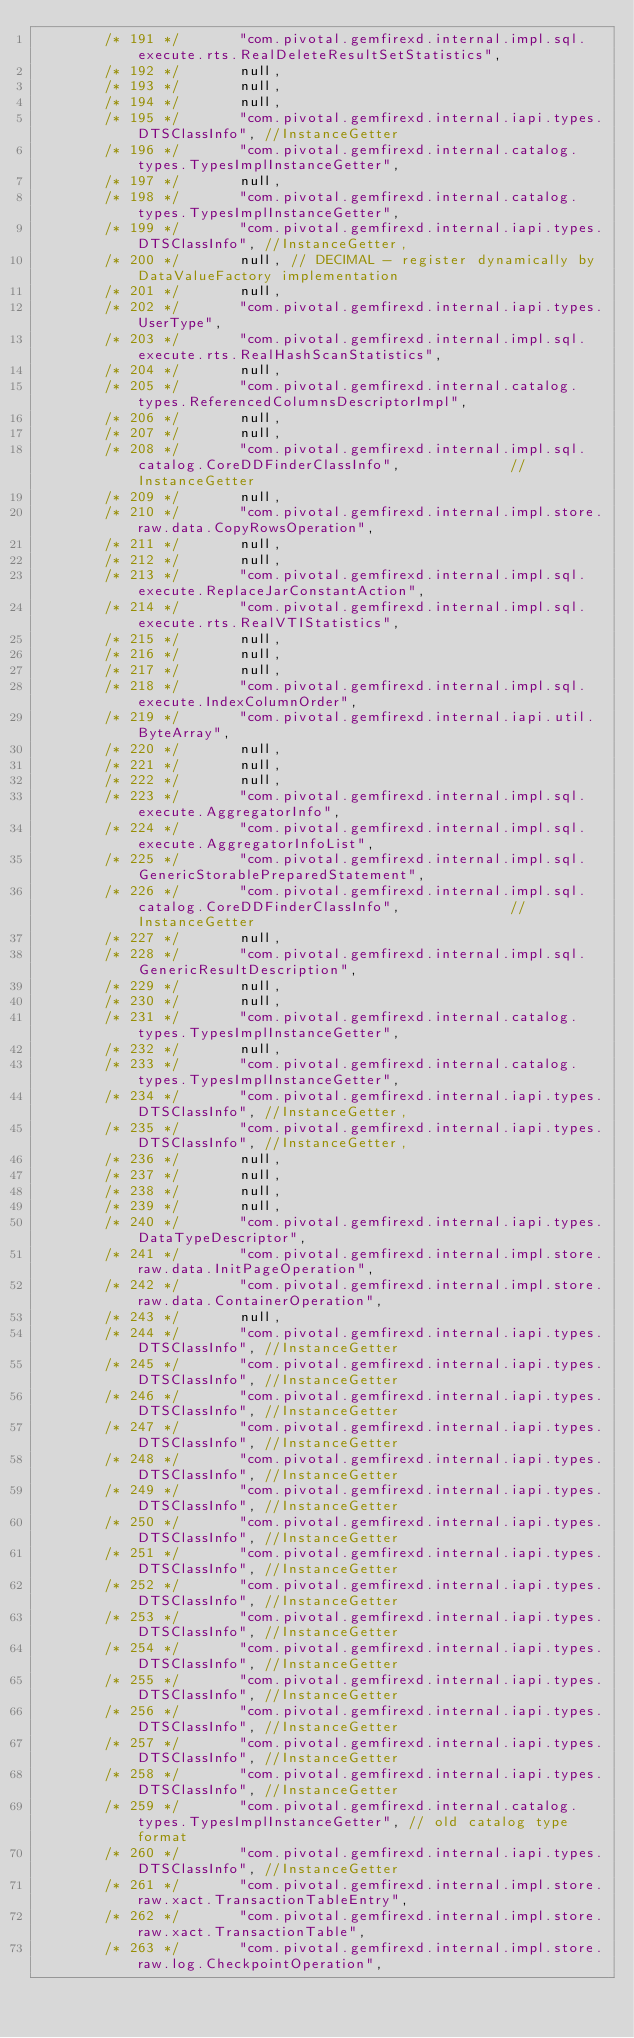<code> <loc_0><loc_0><loc_500><loc_500><_Java_>        /* 191 */       "com.pivotal.gemfirexd.internal.impl.sql.execute.rts.RealDeleteResultSetStatistics",
        /* 192 */       null,
        /* 193 */       null,
        /* 194 */       null,
        /* 195 */       "com.pivotal.gemfirexd.internal.iapi.types.DTSClassInfo", //InstanceGetter
        /* 196 */       "com.pivotal.gemfirexd.internal.catalog.types.TypesImplInstanceGetter",
        /* 197 */       null,
        /* 198 */       "com.pivotal.gemfirexd.internal.catalog.types.TypesImplInstanceGetter",
        /* 199 */       "com.pivotal.gemfirexd.internal.iapi.types.DTSClassInfo", //InstanceGetter,
        /* 200 */       null, // DECIMAL - register dynamically by DataValueFactory implementation
        /* 201 */       null,
        /* 202 */       "com.pivotal.gemfirexd.internal.iapi.types.UserType",
        /* 203 */       "com.pivotal.gemfirexd.internal.impl.sql.execute.rts.RealHashScanStatistics",
        /* 204 */       null,
        /* 205 */       "com.pivotal.gemfirexd.internal.catalog.types.ReferencedColumnsDescriptorImpl",
        /* 206 */       null,
        /* 207 */       null,
        /* 208 */       "com.pivotal.gemfirexd.internal.impl.sql.catalog.CoreDDFinderClassInfo",             // InstanceGetter
        /* 209 */       null,
        /* 210 */       "com.pivotal.gemfirexd.internal.impl.store.raw.data.CopyRowsOperation",
        /* 211 */       null,
        /* 212 */       null,
        /* 213 */       "com.pivotal.gemfirexd.internal.impl.sql.execute.ReplaceJarConstantAction",
        /* 214 */       "com.pivotal.gemfirexd.internal.impl.sql.execute.rts.RealVTIStatistics",
        /* 215 */       null,
        /* 216 */       null,
        /* 217 */       null,
        /* 218 */       "com.pivotal.gemfirexd.internal.impl.sql.execute.IndexColumnOrder",
        /* 219 */       "com.pivotal.gemfirexd.internal.iapi.util.ByteArray",
        /* 220 */       null,
        /* 221 */       null,
        /* 222 */       null,
        /* 223 */       "com.pivotal.gemfirexd.internal.impl.sql.execute.AggregatorInfo",
        /* 224 */       "com.pivotal.gemfirexd.internal.impl.sql.execute.AggregatorInfoList",
        /* 225 */       "com.pivotal.gemfirexd.internal.impl.sql.GenericStorablePreparedStatement",
        /* 226 */       "com.pivotal.gemfirexd.internal.impl.sql.catalog.CoreDDFinderClassInfo",             // InstanceGetter
        /* 227 */       null,
        /* 228 */       "com.pivotal.gemfirexd.internal.impl.sql.GenericResultDescription",
        /* 229 */       null,
        /* 230 */       null,
        /* 231 */       "com.pivotal.gemfirexd.internal.catalog.types.TypesImplInstanceGetter",
        /* 232 */       null,
        /* 233 */       "com.pivotal.gemfirexd.internal.catalog.types.TypesImplInstanceGetter",
        /* 234 */       "com.pivotal.gemfirexd.internal.iapi.types.DTSClassInfo", //InstanceGetter,
        /* 235 */       "com.pivotal.gemfirexd.internal.iapi.types.DTSClassInfo", //InstanceGetter,
        /* 236 */       null,
        /* 237 */       null,
        /* 238 */       null,
        /* 239 */       null,
        /* 240 */       "com.pivotal.gemfirexd.internal.iapi.types.DataTypeDescriptor",
        /* 241 */       "com.pivotal.gemfirexd.internal.impl.store.raw.data.InitPageOperation",
        /* 242 */       "com.pivotal.gemfirexd.internal.impl.store.raw.data.ContainerOperation",
        /* 243 */       null,
        /* 244 */       "com.pivotal.gemfirexd.internal.iapi.types.DTSClassInfo", //InstanceGetter
        /* 245 */       "com.pivotal.gemfirexd.internal.iapi.types.DTSClassInfo", //InstanceGetter
        /* 246 */       "com.pivotal.gemfirexd.internal.iapi.types.DTSClassInfo", //InstanceGetter
        /* 247 */       "com.pivotal.gemfirexd.internal.iapi.types.DTSClassInfo", //InstanceGetter
        /* 248 */       "com.pivotal.gemfirexd.internal.iapi.types.DTSClassInfo", //InstanceGetter
        /* 249 */       "com.pivotal.gemfirexd.internal.iapi.types.DTSClassInfo", //InstanceGetter
        /* 250 */       "com.pivotal.gemfirexd.internal.iapi.types.DTSClassInfo", //InstanceGetter
        /* 251 */       "com.pivotal.gemfirexd.internal.iapi.types.DTSClassInfo", //InstanceGetter
        /* 252 */       "com.pivotal.gemfirexd.internal.iapi.types.DTSClassInfo", //InstanceGetter
        /* 253 */       "com.pivotal.gemfirexd.internal.iapi.types.DTSClassInfo", //InstanceGetter
        /* 254 */       "com.pivotal.gemfirexd.internal.iapi.types.DTSClassInfo", //InstanceGetter
        /* 255 */       "com.pivotal.gemfirexd.internal.iapi.types.DTSClassInfo", //InstanceGetter
        /* 256 */       "com.pivotal.gemfirexd.internal.iapi.types.DTSClassInfo", //InstanceGetter
        /* 257 */       "com.pivotal.gemfirexd.internal.iapi.types.DTSClassInfo", //InstanceGetter
        /* 258 */       "com.pivotal.gemfirexd.internal.iapi.types.DTSClassInfo", //InstanceGetter
        /* 259 */       "com.pivotal.gemfirexd.internal.catalog.types.TypesImplInstanceGetter", // old catalog type format
        /* 260 */       "com.pivotal.gemfirexd.internal.iapi.types.DTSClassInfo", //InstanceGetter
        /* 261 */       "com.pivotal.gemfirexd.internal.impl.store.raw.xact.TransactionTableEntry",
        /* 262 */       "com.pivotal.gemfirexd.internal.impl.store.raw.xact.TransactionTable",
        /* 263 */       "com.pivotal.gemfirexd.internal.impl.store.raw.log.CheckpointOperation",</code> 